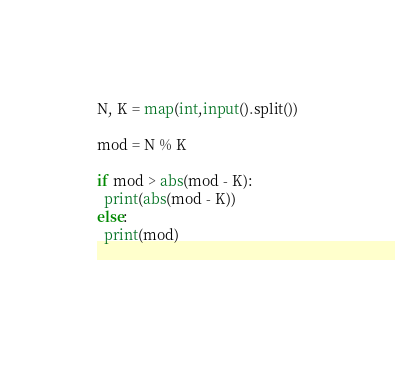Convert code to text. <code><loc_0><loc_0><loc_500><loc_500><_Python_>N, K = map(int,input().split())

mod = N % K

if mod > abs(mod - K):
  print(abs(mod - K))
else:
  print(mod)

  </code> 